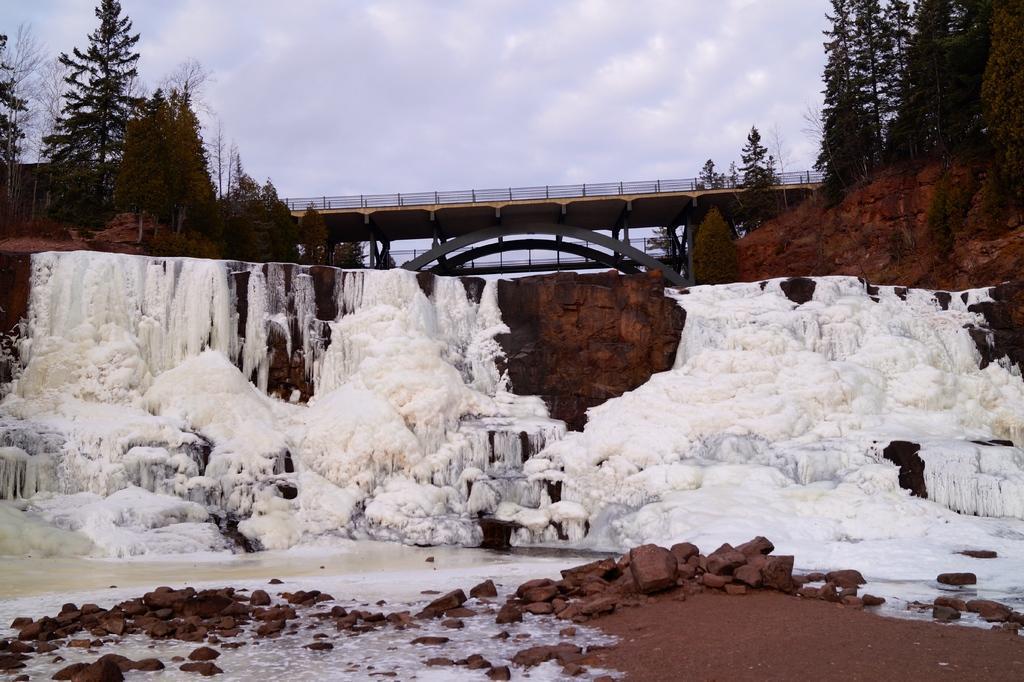Please provide a concise description of this image. In this image there is a snow, in the background there is a bridge, on either side of the bridge there are trees and there is a sky. 